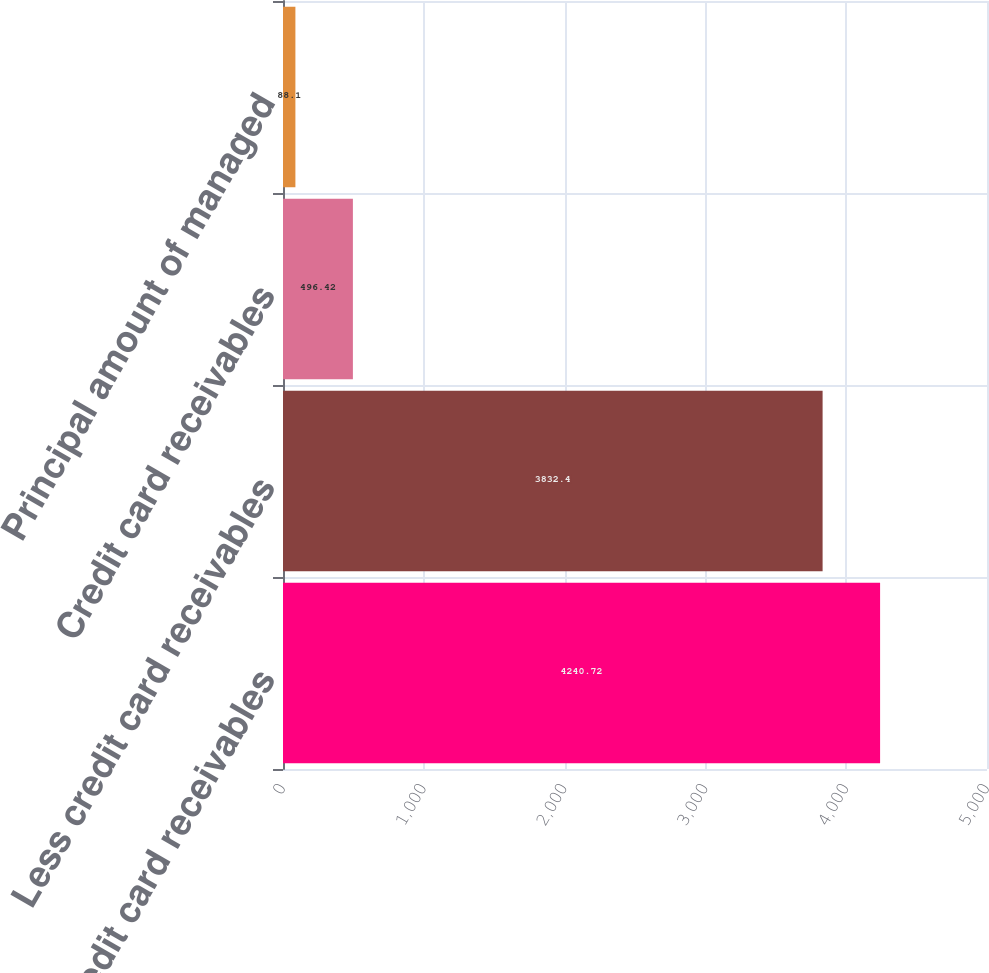Convert chart to OTSL. <chart><loc_0><loc_0><loc_500><loc_500><bar_chart><fcel>Total credit card receivables<fcel>Less credit card receivables<fcel>Credit card receivables<fcel>Principal amount of managed<nl><fcel>4240.72<fcel>3832.4<fcel>496.42<fcel>88.1<nl></chart> 